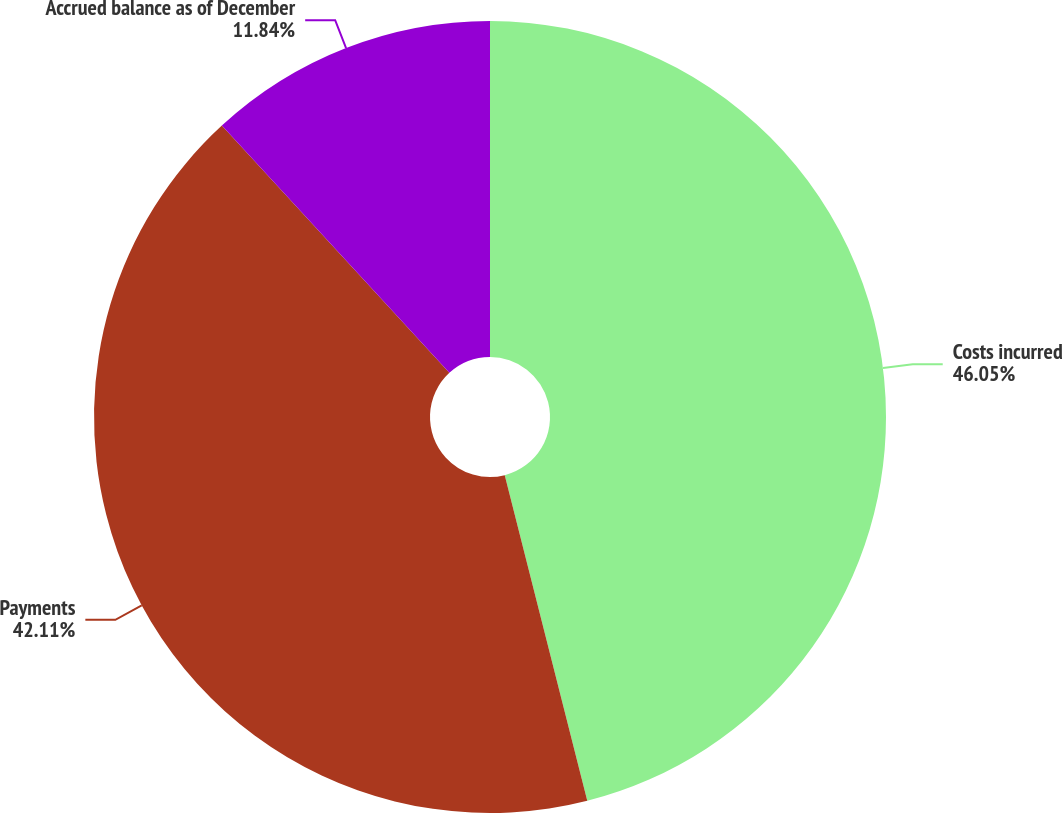Convert chart. <chart><loc_0><loc_0><loc_500><loc_500><pie_chart><fcel>Costs incurred<fcel>Payments<fcel>Accrued balance as of December<nl><fcel>46.05%<fcel>42.11%<fcel>11.84%<nl></chart> 